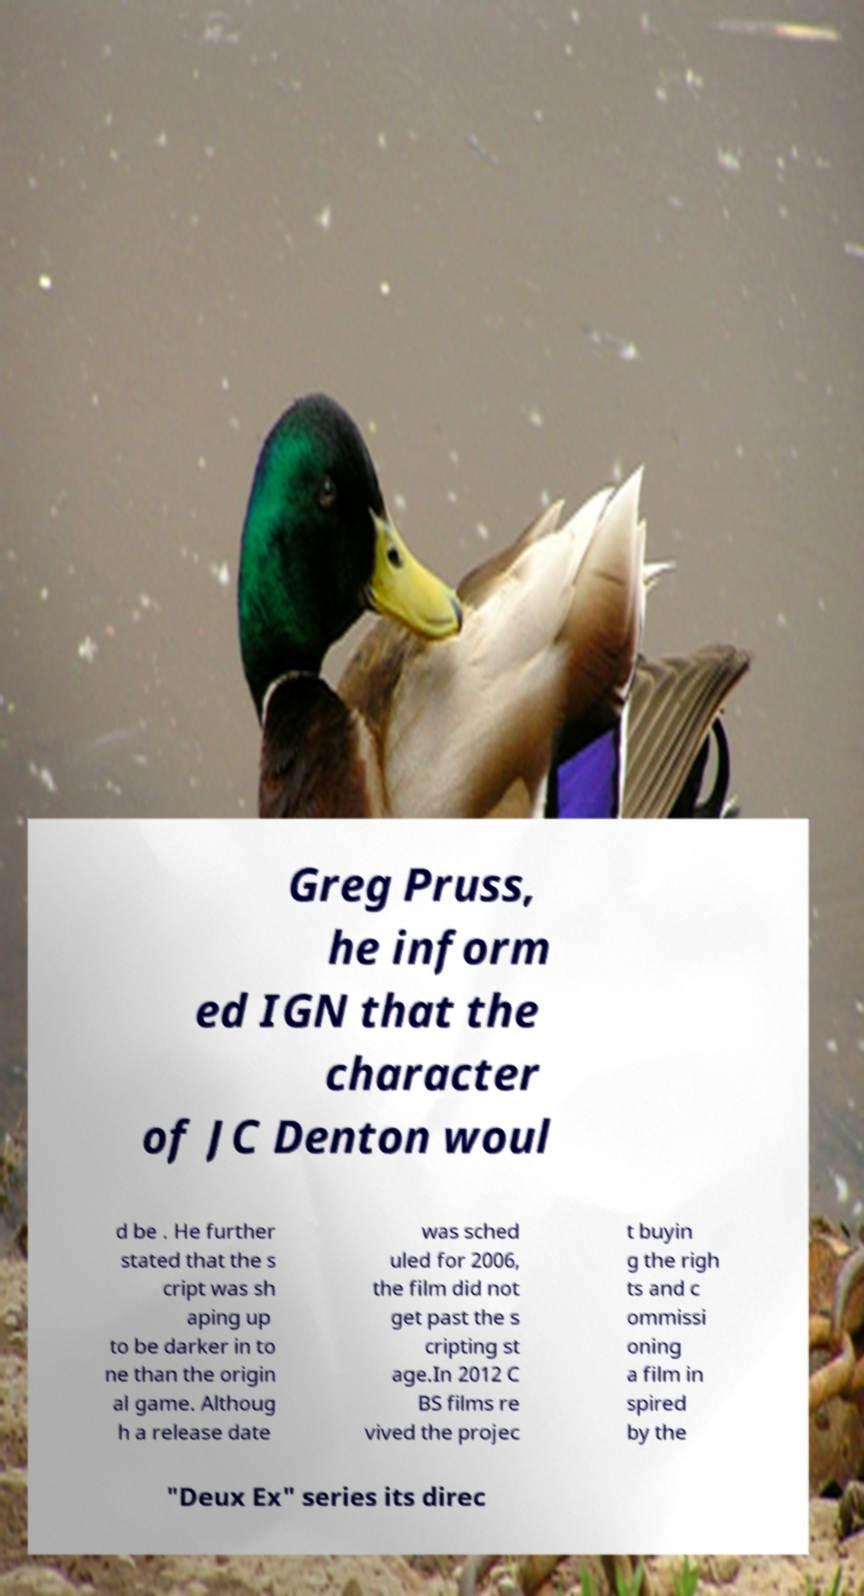I need the written content from this picture converted into text. Can you do that? Greg Pruss, he inform ed IGN that the character of JC Denton woul d be . He further stated that the s cript was sh aping up to be darker in to ne than the origin al game. Althoug h a release date was sched uled for 2006, the film did not get past the s cripting st age.In 2012 C BS films re vived the projec t buyin g the righ ts and c ommissi oning a film in spired by the "Deux Ex" series its direc 